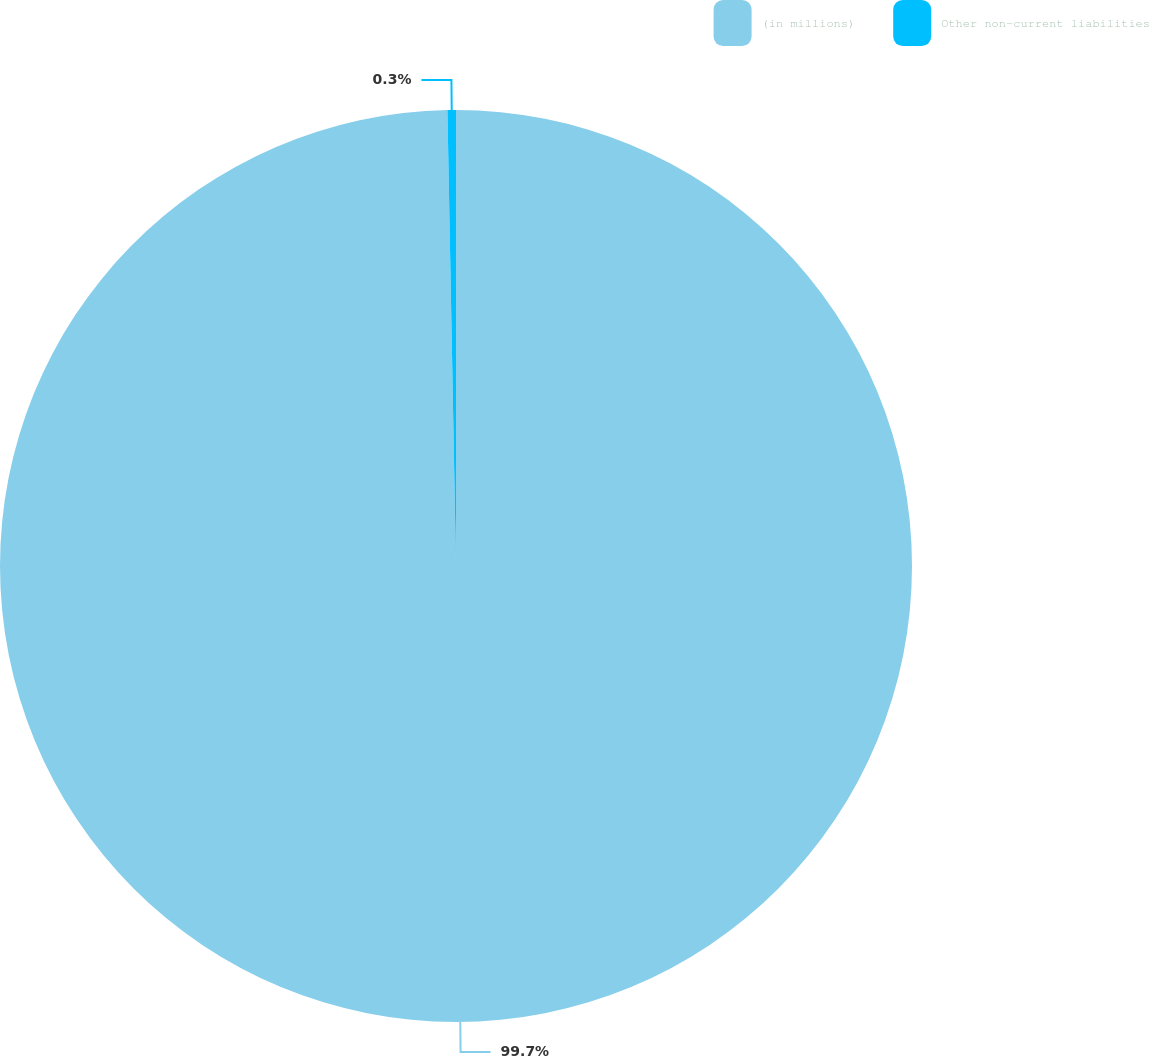<chart> <loc_0><loc_0><loc_500><loc_500><pie_chart><fcel>(in millions)<fcel>Other non-current liabilities<nl><fcel>99.7%<fcel>0.3%<nl></chart> 